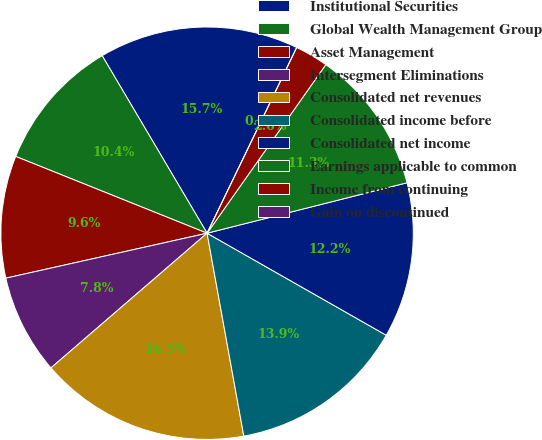Convert chart. <chart><loc_0><loc_0><loc_500><loc_500><pie_chart><fcel>Institutional Securities<fcel>Global Wealth Management Group<fcel>Asset Management<fcel>Intersegment Eliminations<fcel>Consolidated net revenues<fcel>Consolidated income before<fcel>Consolidated net income<fcel>Earnings applicable to common<fcel>Income from continuing<fcel>Gain on discontinued<nl><fcel>15.65%<fcel>10.43%<fcel>9.57%<fcel>7.83%<fcel>16.52%<fcel>13.91%<fcel>12.17%<fcel>11.3%<fcel>2.61%<fcel>0.0%<nl></chart> 